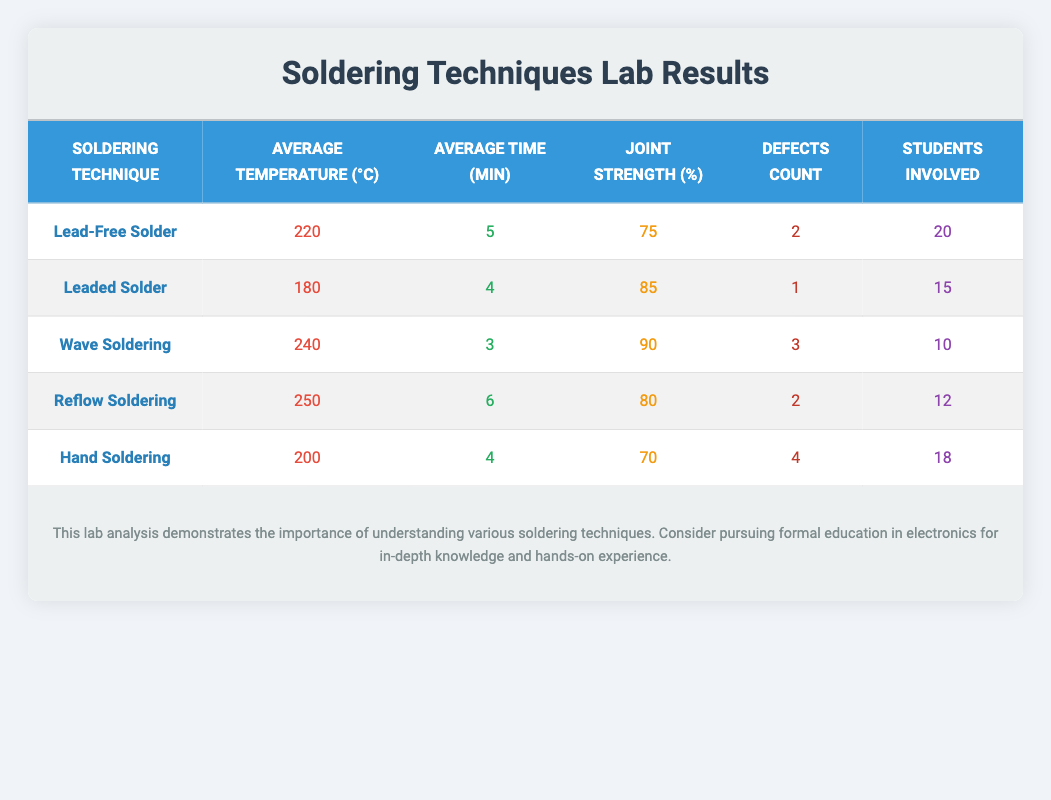What is the joint strength percentage for Wave Soldering? According to the table, the joint strength for Wave Soldering is recorded as 90%.
Answer: 90% How many students were involved in the Lead-Free Solder experiments? The table shows that 20 students were involved in the Lead-Free Solder experiments.
Answer: 20 Which soldering technique has the highest defects count? Comparing the defects count for all techniques, Hand Soldering has the highest defects count at 4.
Answer: Hand Soldering What is the average temperature of Reflow Soldering? The table states that the average temperature for Reflow Soldering is 250°C.
Answer: 250°C Calculate the total joint strength of all soldering techniques. Sum the joint strengths: 75 + 85 + 90 + 80 + 70 = 400. Therefore, the total joint strength is 400%.
Answer: 400% Which soldering technique had the lowest average time spent? Reviewing the average time spent, Wave Soldering has the lowest average time of 3 minutes.
Answer: Wave Soldering Is the average temperature of Lead-Free Solder higher than that of Leaded Solder? The average temperature for Lead-Free Solder is 220°C, while for Leaded Solder, it is 180°C. Since 220 is greater than 180, the answer is yes.
Answer: Yes If we take the average joint strength of Hand Soldering and Reflow Soldering, what is it? The joint strengths for Hand Soldering and Reflow Soldering are 70% and 80%, so the average is (70 + 80) / 2 = 75%.
Answer: 75% Which soldering technique involved the least number of students? The table indicates that Wave Soldering involved the least number of students, at 10.
Answer: 10 What is the difference in average temperature between Wave Soldering and Hand Soldering? The average temperature for Wave Soldering is 240°C and for Hand Soldering is 200°C. The difference is 240 - 200 = 40°C.
Answer: 40°C 